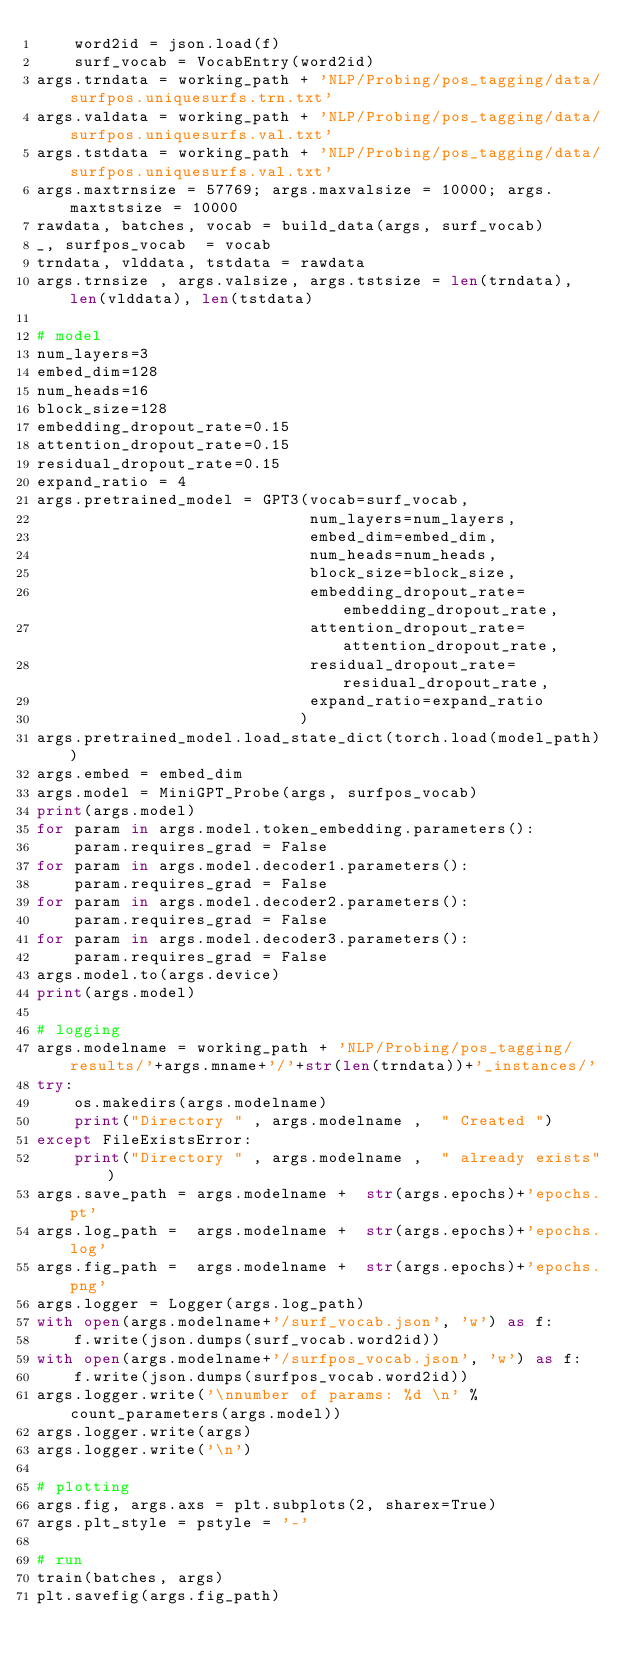<code> <loc_0><loc_0><loc_500><loc_500><_Python_>    word2id = json.load(f)
    surf_vocab = VocabEntry(word2id)
args.trndata = working_path + 'NLP/Probing/pos_tagging/data/surfpos.uniquesurfs.trn.txt' 
args.valdata = working_path + 'NLP/Probing/pos_tagging/data/surfpos.uniquesurfs.val.txt'
args.tstdata = working_path + 'NLP/Probing/pos_tagging/data/surfpos.uniquesurfs.val.txt' 
args.maxtrnsize = 57769; args.maxvalsize = 10000; args.maxtstsize = 10000
rawdata, batches, vocab = build_data(args, surf_vocab)
_, surfpos_vocab  = vocab
trndata, vlddata, tstdata = rawdata
args.trnsize , args.valsize, args.tstsize = len(trndata), len(vlddata), len(tstdata)

# model
num_layers=3
embed_dim=128
num_heads=16
block_size=128
embedding_dropout_rate=0.15 
attention_dropout_rate=0.15
residual_dropout_rate=0.15
expand_ratio = 4
args.pretrained_model = GPT3(vocab=surf_vocab,
                             num_layers=num_layers,
                             embed_dim=embed_dim,
                             num_heads=num_heads,
                             block_size=block_size,
                             embedding_dropout_rate=embedding_dropout_rate,
                             attention_dropout_rate=attention_dropout_rate,
                             residual_dropout_rate=residual_dropout_rate,
                             expand_ratio=expand_ratio
                            )
args.pretrained_model.load_state_dict(torch.load(model_path))
args.embed = embed_dim
args.model = MiniGPT_Probe(args, surfpos_vocab)
print(args.model)
for param in args.model.token_embedding.parameters():
    param.requires_grad = False
for param in args.model.decoder1.parameters():
    param.requires_grad = False
for param in args.model.decoder2.parameters():
    param.requires_grad = False
for param in args.model.decoder3.parameters():
    param.requires_grad = False
args.model.to(args.device)
print(args.model)

# logging
args.modelname = working_path + 'NLP/Probing/pos_tagging/results/'+args.mname+'/'+str(len(trndata))+'_instances/'
try:
    os.makedirs(args.modelname)
    print("Directory " , args.modelname ,  " Created ") 
except FileExistsError:
    print("Directory " , args.modelname ,  " already exists")
args.save_path = args.modelname +  str(args.epochs)+'epochs.pt'
args.log_path =  args.modelname +  str(args.epochs)+'epochs.log'
args.fig_path =  args.modelname +  str(args.epochs)+'epochs.png'
args.logger = Logger(args.log_path)
with open(args.modelname+'/surf_vocab.json', 'w') as f:
    f.write(json.dumps(surf_vocab.word2id))
with open(args.modelname+'/surfpos_vocab.json', 'w') as f:
    f.write(json.dumps(surfpos_vocab.word2id))
args.logger.write('\nnumber of params: %d \n' % count_parameters(args.model))
args.logger.write(args)
args.logger.write('\n')

# plotting
args.fig, args.axs = plt.subplots(2, sharex=True)
args.plt_style = pstyle = '-'

# run
train(batches, args)
plt.savefig(args.fig_path)


  </code> 